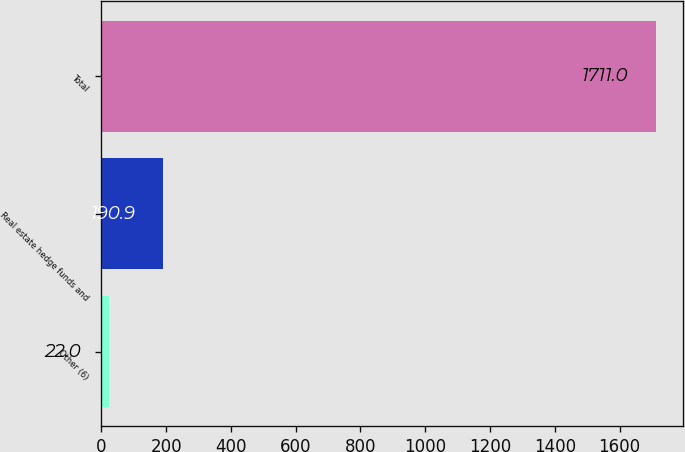Convert chart to OTSL. <chart><loc_0><loc_0><loc_500><loc_500><bar_chart><fcel>Other (6)<fcel>Real estate hedge funds and<fcel>Total<nl><fcel>22<fcel>190.9<fcel>1711<nl></chart> 